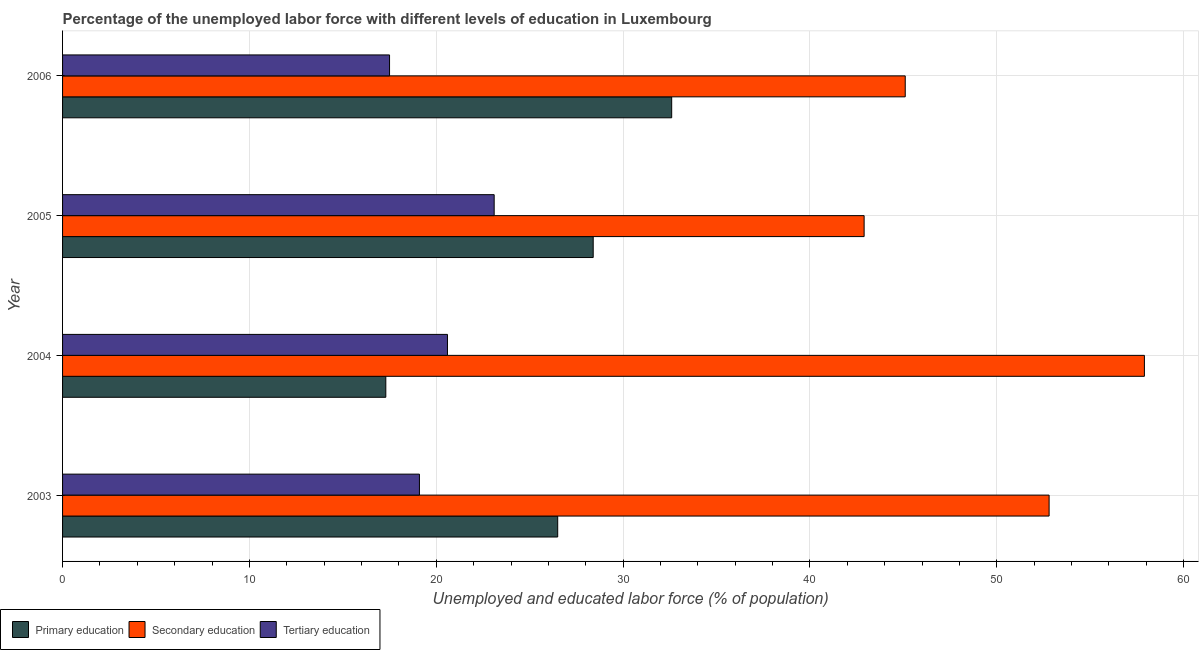How many groups of bars are there?
Give a very brief answer. 4. Are the number of bars per tick equal to the number of legend labels?
Your answer should be very brief. Yes. How many bars are there on the 1st tick from the top?
Make the answer very short. 3. In how many cases, is the number of bars for a given year not equal to the number of legend labels?
Offer a very short reply. 0. What is the percentage of labor force who received secondary education in 2003?
Offer a terse response. 52.8. Across all years, what is the maximum percentage of labor force who received primary education?
Provide a short and direct response. 32.6. Across all years, what is the minimum percentage of labor force who received secondary education?
Offer a very short reply. 42.9. In which year was the percentage of labor force who received primary education maximum?
Your answer should be very brief. 2006. What is the total percentage of labor force who received secondary education in the graph?
Provide a succinct answer. 198.7. What is the difference between the percentage of labor force who received primary education in 2003 and that in 2005?
Give a very brief answer. -1.9. What is the difference between the percentage of labor force who received tertiary education in 2003 and the percentage of labor force who received primary education in 2006?
Your answer should be very brief. -13.5. What is the average percentage of labor force who received tertiary education per year?
Offer a very short reply. 20.07. In the year 2004, what is the difference between the percentage of labor force who received tertiary education and percentage of labor force who received primary education?
Provide a succinct answer. 3.3. What is the ratio of the percentage of labor force who received tertiary education in 2003 to that in 2006?
Provide a succinct answer. 1.09. Is the percentage of labor force who received tertiary education in 2003 less than that in 2006?
Give a very brief answer. No. What is the difference between the highest and the second highest percentage of labor force who received primary education?
Provide a short and direct response. 4.2. In how many years, is the percentage of labor force who received secondary education greater than the average percentage of labor force who received secondary education taken over all years?
Give a very brief answer. 2. What does the 2nd bar from the top in 2006 represents?
Provide a short and direct response. Secondary education. What does the 2nd bar from the bottom in 2004 represents?
Make the answer very short. Secondary education. Is it the case that in every year, the sum of the percentage of labor force who received primary education and percentage of labor force who received secondary education is greater than the percentage of labor force who received tertiary education?
Keep it short and to the point. Yes. Are all the bars in the graph horizontal?
Your response must be concise. Yes. Does the graph contain any zero values?
Give a very brief answer. No. Does the graph contain grids?
Provide a succinct answer. Yes. Where does the legend appear in the graph?
Ensure brevity in your answer.  Bottom left. How many legend labels are there?
Provide a succinct answer. 3. What is the title of the graph?
Your answer should be compact. Percentage of the unemployed labor force with different levels of education in Luxembourg. Does "ICT services" appear as one of the legend labels in the graph?
Provide a succinct answer. No. What is the label or title of the X-axis?
Make the answer very short. Unemployed and educated labor force (% of population). What is the Unemployed and educated labor force (% of population) of Primary education in 2003?
Offer a very short reply. 26.5. What is the Unemployed and educated labor force (% of population) of Secondary education in 2003?
Your answer should be very brief. 52.8. What is the Unemployed and educated labor force (% of population) of Tertiary education in 2003?
Provide a succinct answer. 19.1. What is the Unemployed and educated labor force (% of population) in Primary education in 2004?
Your answer should be compact. 17.3. What is the Unemployed and educated labor force (% of population) of Secondary education in 2004?
Provide a short and direct response. 57.9. What is the Unemployed and educated labor force (% of population) of Tertiary education in 2004?
Ensure brevity in your answer.  20.6. What is the Unemployed and educated labor force (% of population) of Primary education in 2005?
Offer a very short reply. 28.4. What is the Unemployed and educated labor force (% of population) of Secondary education in 2005?
Give a very brief answer. 42.9. What is the Unemployed and educated labor force (% of population) of Tertiary education in 2005?
Make the answer very short. 23.1. What is the Unemployed and educated labor force (% of population) in Primary education in 2006?
Provide a short and direct response. 32.6. What is the Unemployed and educated labor force (% of population) of Secondary education in 2006?
Provide a short and direct response. 45.1. Across all years, what is the maximum Unemployed and educated labor force (% of population) of Primary education?
Your response must be concise. 32.6. Across all years, what is the maximum Unemployed and educated labor force (% of population) in Secondary education?
Provide a succinct answer. 57.9. Across all years, what is the maximum Unemployed and educated labor force (% of population) of Tertiary education?
Offer a terse response. 23.1. Across all years, what is the minimum Unemployed and educated labor force (% of population) in Primary education?
Ensure brevity in your answer.  17.3. Across all years, what is the minimum Unemployed and educated labor force (% of population) in Secondary education?
Offer a terse response. 42.9. Across all years, what is the minimum Unemployed and educated labor force (% of population) of Tertiary education?
Keep it short and to the point. 17.5. What is the total Unemployed and educated labor force (% of population) of Primary education in the graph?
Give a very brief answer. 104.8. What is the total Unemployed and educated labor force (% of population) in Secondary education in the graph?
Provide a short and direct response. 198.7. What is the total Unemployed and educated labor force (% of population) in Tertiary education in the graph?
Your response must be concise. 80.3. What is the difference between the Unemployed and educated labor force (% of population) in Primary education in 2003 and that in 2004?
Provide a short and direct response. 9.2. What is the difference between the Unemployed and educated labor force (% of population) in Secondary education in 2003 and that in 2006?
Provide a succinct answer. 7.7. What is the difference between the Unemployed and educated labor force (% of population) in Tertiary education in 2003 and that in 2006?
Provide a short and direct response. 1.6. What is the difference between the Unemployed and educated labor force (% of population) of Primary education in 2004 and that in 2005?
Your response must be concise. -11.1. What is the difference between the Unemployed and educated labor force (% of population) in Tertiary education in 2004 and that in 2005?
Your answer should be compact. -2.5. What is the difference between the Unemployed and educated labor force (% of population) of Primary education in 2004 and that in 2006?
Your answer should be compact. -15.3. What is the difference between the Unemployed and educated labor force (% of population) of Secondary education in 2004 and that in 2006?
Ensure brevity in your answer.  12.8. What is the difference between the Unemployed and educated labor force (% of population) in Tertiary education in 2004 and that in 2006?
Provide a succinct answer. 3.1. What is the difference between the Unemployed and educated labor force (% of population) in Primary education in 2005 and that in 2006?
Your answer should be compact. -4.2. What is the difference between the Unemployed and educated labor force (% of population) of Secondary education in 2005 and that in 2006?
Ensure brevity in your answer.  -2.2. What is the difference between the Unemployed and educated labor force (% of population) of Primary education in 2003 and the Unemployed and educated labor force (% of population) of Secondary education in 2004?
Provide a short and direct response. -31.4. What is the difference between the Unemployed and educated labor force (% of population) of Primary education in 2003 and the Unemployed and educated labor force (% of population) of Tertiary education in 2004?
Provide a short and direct response. 5.9. What is the difference between the Unemployed and educated labor force (% of population) in Secondary education in 2003 and the Unemployed and educated labor force (% of population) in Tertiary education in 2004?
Keep it short and to the point. 32.2. What is the difference between the Unemployed and educated labor force (% of population) of Primary education in 2003 and the Unemployed and educated labor force (% of population) of Secondary education in 2005?
Offer a terse response. -16.4. What is the difference between the Unemployed and educated labor force (% of population) of Secondary education in 2003 and the Unemployed and educated labor force (% of population) of Tertiary education in 2005?
Make the answer very short. 29.7. What is the difference between the Unemployed and educated labor force (% of population) in Primary education in 2003 and the Unemployed and educated labor force (% of population) in Secondary education in 2006?
Make the answer very short. -18.6. What is the difference between the Unemployed and educated labor force (% of population) in Primary education in 2003 and the Unemployed and educated labor force (% of population) in Tertiary education in 2006?
Give a very brief answer. 9. What is the difference between the Unemployed and educated labor force (% of population) in Secondary education in 2003 and the Unemployed and educated labor force (% of population) in Tertiary education in 2006?
Offer a very short reply. 35.3. What is the difference between the Unemployed and educated labor force (% of population) of Primary education in 2004 and the Unemployed and educated labor force (% of population) of Secondary education in 2005?
Provide a succinct answer. -25.6. What is the difference between the Unemployed and educated labor force (% of population) of Primary education in 2004 and the Unemployed and educated labor force (% of population) of Tertiary education in 2005?
Give a very brief answer. -5.8. What is the difference between the Unemployed and educated labor force (% of population) in Secondary education in 2004 and the Unemployed and educated labor force (% of population) in Tertiary education in 2005?
Your response must be concise. 34.8. What is the difference between the Unemployed and educated labor force (% of population) in Primary education in 2004 and the Unemployed and educated labor force (% of population) in Secondary education in 2006?
Give a very brief answer. -27.8. What is the difference between the Unemployed and educated labor force (% of population) of Primary education in 2004 and the Unemployed and educated labor force (% of population) of Tertiary education in 2006?
Offer a very short reply. -0.2. What is the difference between the Unemployed and educated labor force (% of population) in Secondary education in 2004 and the Unemployed and educated labor force (% of population) in Tertiary education in 2006?
Your response must be concise. 40.4. What is the difference between the Unemployed and educated labor force (% of population) in Primary education in 2005 and the Unemployed and educated labor force (% of population) in Secondary education in 2006?
Offer a terse response. -16.7. What is the difference between the Unemployed and educated labor force (% of population) of Primary education in 2005 and the Unemployed and educated labor force (% of population) of Tertiary education in 2006?
Your answer should be very brief. 10.9. What is the difference between the Unemployed and educated labor force (% of population) in Secondary education in 2005 and the Unemployed and educated labor force (% of population) in Tertiary education in 2006?
Your answer should be very brief. 25.4. What is the average Unemployed and educated labor force (% of population) in Primary education per year?
Offer a very short reply. 26.2. What is the average Unemployed and educated labor force (% of population) in Secondary education per year?
Provide a succinct answer. 49.67. What is the average Unemployed and educated labor force (% of population) in Tertiary education per year?
Keep it short and to the point. 20.07. In the year 2003, what is the difference between the Unemployed and educated labor force (% of population) of Primary education and Unemployed and educated labor force (% of population) of Secondary education?
Your answer should be compact. -26.3. In the year 2003, what is the difference between the Unemployed and educated labor force (% of population) in Primary education and Unemployed and educated labor force (% of population) in Tertiary education?
Your answer should be compact. 7.4. In the year 2003, what is the difference between the Unemployed and educated labor force (% of population) of Secondary education and Unemployed and educated labor force (% of population) of Tertiary education?
Provide a short and direct response. 33.7. In the year 2004, what is the difference between the Unemployed and educated labor force (% of population) of Primary education and Unemployed and educated labor force (% of population) of Secondary education?
Your answer should be compact. -40.6. In the year 2004, what is the difference between the Unemployed and educated labor force (% of population) in Primary education and Unemployed and educated labor force (% of population) in Tertiary education?
Your answer should be compact. -3.3. In the year 2004, what is the difference between the Unemployed and educated labor force (% of population) in Secondary education and Unemployed and educated labor force (% of population) in Tertiary education?
Provide a succinct answer. 37.3. In the year 2005, what is the difference between the Unemployed and educated labor force (% of population) of Primary education and Unemployed and educated labor force (% of population) of Secondary education?
Your answer should be very brief. -14.5. In the year 2005, what is the difference between the Unemployed and educated labor force (% of population) in Secondary education and Unemployed and educated labor force (% of population) in Tertiary education?
Give a very brief answer. 19.8. In the year 2006, what is the difference between the Unemployed and educated labor force (% of population) of Primary education and Unemployed and educated labor force (% of population) of Tertiary education?
Your answer should be compact. 15.1. In the year 2006, what is the difference between the Unemployed and educated labor force (% of population) of Secondary education and Unemployed and educated labor force (% of population) of Tertiary education?
Provide a succinct answer. 27.6. What is the ratio of the Unemployed and educated labor force (% of population) in Primary education in 2003 to that in 2004?
Offer a terse response. 1.53. What is the ratio of the Unemployed and educated labor force (% of population) in Secondary education in 2003 to that in 2004?
Your response must be concise. 0.91. What is the ratio of the Unemployed and educated labor force (% of population) of Tertiary education in 2003 to that in 2004?
Provide a short and direct response. 0.93. What is the ratio of the Unemployed and educated labor force (% of population) of Primary education in 2003 to that in 2005?
Offer a terse response. 0.93. What is the ratio of the Unemployed and educated labor force (% of population) in Secondary education in 2003 to that in 2005?
Give a very brief answer. 1.23. What is the ratio of the Unemployed and educated labor force (% of population) in Tertiary education in 2003 to that in 2005?
Give a very brief answer. 0.83. What is the ratio of the Unemployed and educated labor force (% of population) in Primary education in 2003 to that in 2006?
Your response must be concise. 0.81. What is the ratio of the Unemployed and educated labor force (% of population) in Secondary education in 2003 to that in 2006?
Offer a terse response. 1.17. What is the ratio of the Unemployed and educated labor force (% of population) of Tertiary education in 2003 to that in 2006?
Give a very brief answer. 1.09. What is the ratio of the Unemployed and educated labor force (% of population) of Primary education in 2004 to that in 2005?
Offer a terse response. 0.61. What is the ratio of the Unemployed and educated labor force (% of population) in Secondary education in 2004 to that in 2005?
Offer a terse response. 1.35. What is the ratio of the Unemployed and educated labor force (% of population) in Tertiary education in 2004 to that in 2005?
Make the answer very short. 0.89. What is the ratio of the Unemployed and educated labor force (% of population) of Primary education in 2004 to that in 2006?
Make the answer very short. 0.53. What is the ratio of the Unemployed and educated labor force (% of population) in Secondary education in 2004 to that in 2006?
Make the answer very short. 1.28. What is the ratio of the Unemployed and educated labor force (% of population) of Tertiary education in 2004 to that in 2006?
Your response must be concise. 1.18. What is the ratio of the Unemployed and educated labor force (% of population) in Primary education in 2005 to that in 2006?
Provide a succinct answer. 0.87. What is the ratio of the Unemployed and educated labor force (% of population) of Secondary education in 2005 to that in 2006?
Keep it short and to the point. 0.95. What is the ratio of the Unemployed and educated labor force (% of population) of Tertiary education in 2005 to that in 2006?
Ensure brevity in your answer.  1.32. What is the difference between the highest and the second highest Unemployed and educated labor force (% of population) of Primary education?
Provide a succinct answer. 4.2. What is the difference between the highest and the lowest Unemployed and educated labor force (% of population) in Primary education?
Keep it short and to the point. 15.3. What is the difference between the highest and the lowest Unemployed and educated labor force (% of population) in Secondary education?
Your response must be concise. 15. What is the difference between the highest and the lowest Unemployed and educated labor force (% of population) in Tertiary education?
Offer a very short reply. 5.6. 